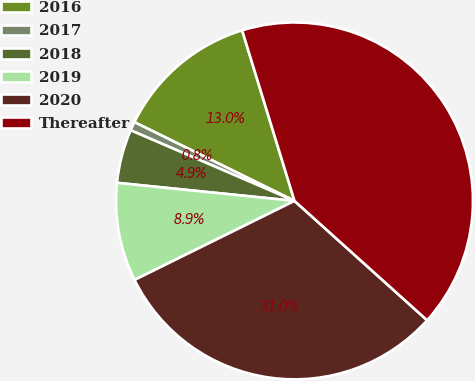Convert chart to OTSL. <chart><loc_0><loc_0><loc_500><loc_500><pie_chart><fcel>2016<fcel>2017<fcel>2018<fcel>2019<fcel>2020<fcel>Thereafter<nl><fcel>12.98%<fcel>0.8%<fcel>4.86%<fcel>8.92%<fcel>31.03%<fcel>41.4%<nl></chart> 